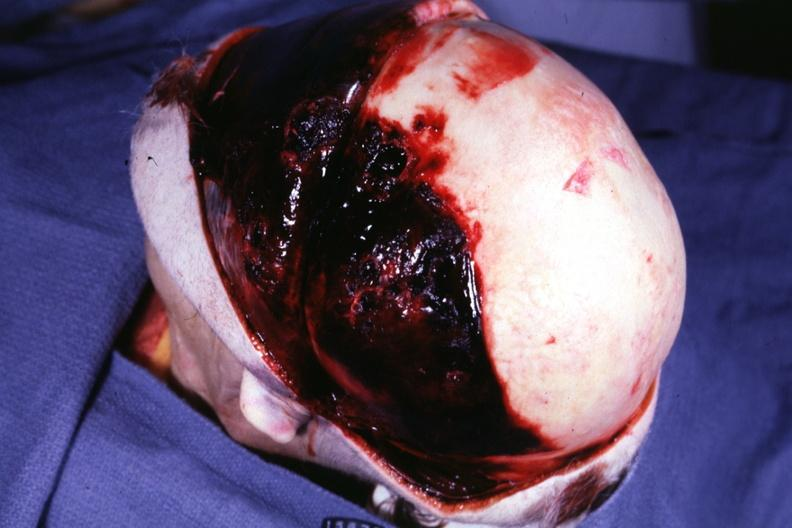what has basal skull fracture chronic subdural hematoma malignant lymphoma and acute myelogenous leukemia?
Answer the question using a single word or phrase. This protocol 